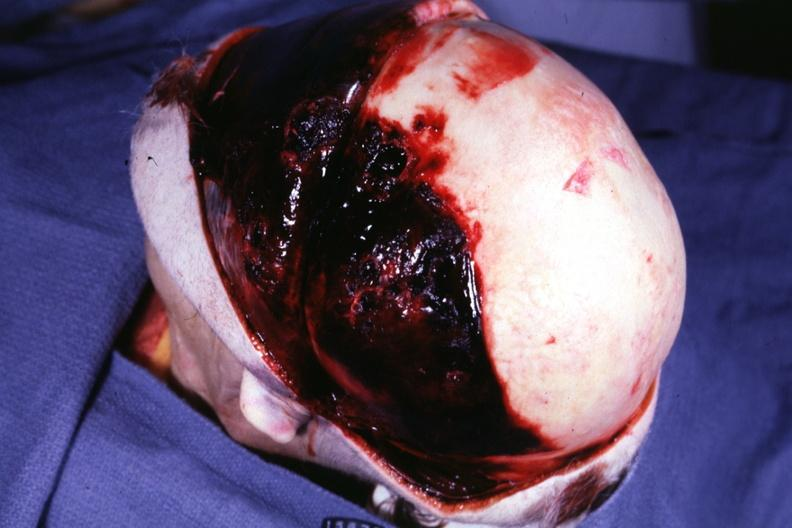what has basal skull fracture chronic subdural hematoma malignant lymphoma and acute myelogenous leukemia?
Answer the question using a single word or phrase. This protocol 